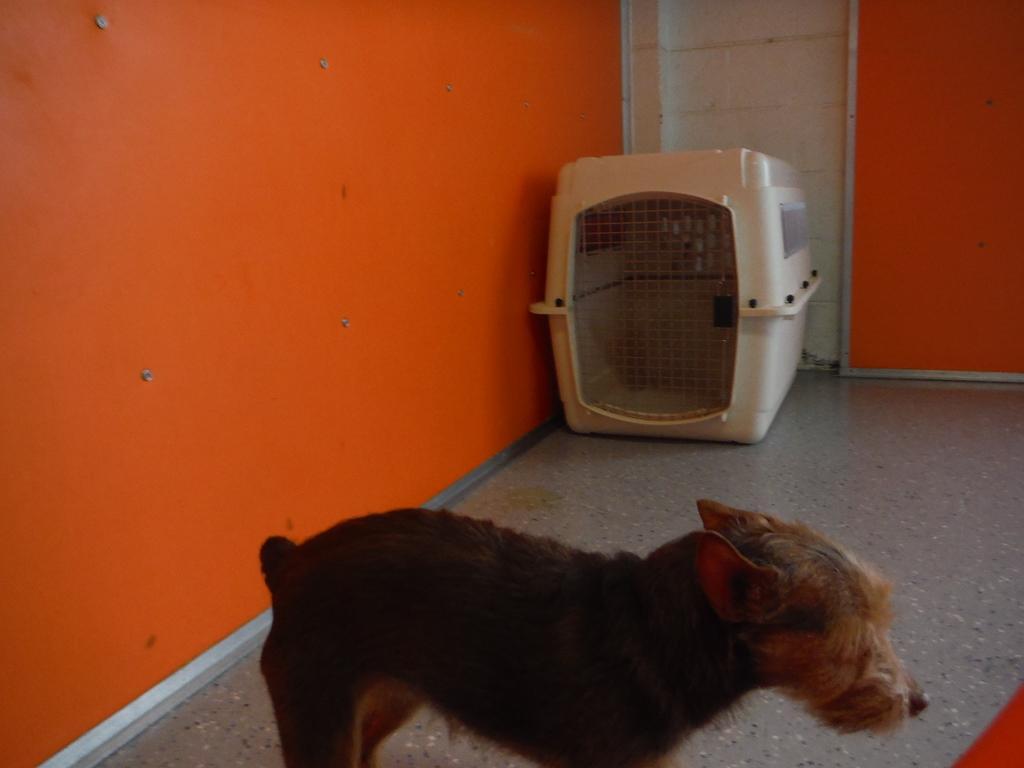Please provide a concise description of this image. In the image there is a dog standing in front of orange wall, in the back there is a cage. 